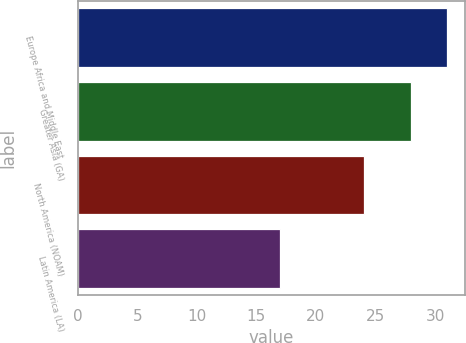Convert chart. <chart><loc_0><loc_0><loc_500><loc_500><bar_chart><fcel>Europe Africa and Middle East<fcel>Greater Asia (GA)<fcel>North America (NOAM)<fcel>Latin America (LA)<nl><fcel>31<fcel>28<fcel>24<fcel>17<nl></chart> 